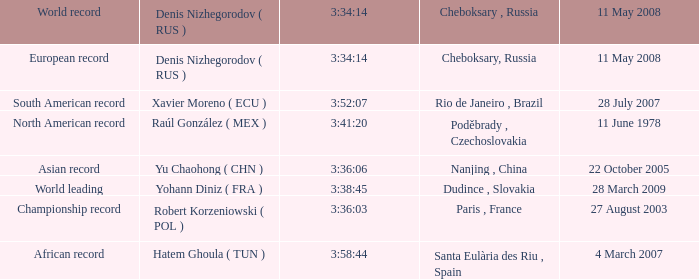When north american record is the world record who is the denis nizhegorodov ( rus )? Raúl González ( MEX ). 